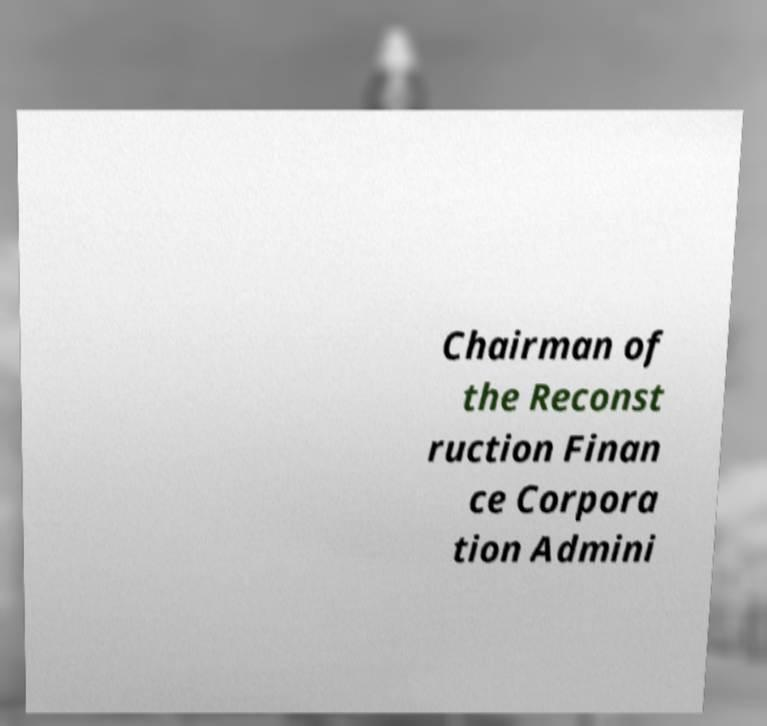Can you accurately transcribe the text from the provided image for me? Chairman of the Reconst ruction Finan ce Corpora tion Admini 